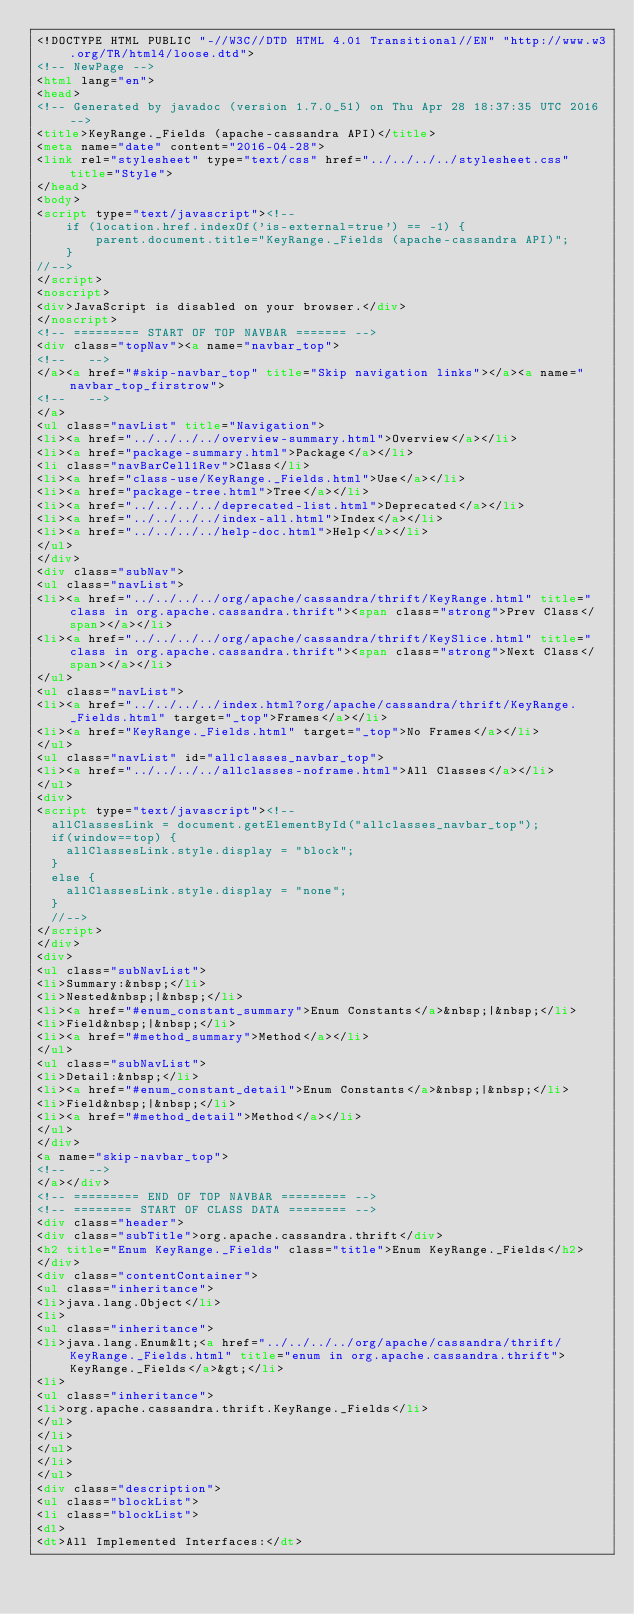Convert code to text. <code><loc_0><loc_0><loc_500><loc_500><_HTML_><!DOCTYPE HTML PUBLIC "-//W3C//DTD HTML 4.01 Transitional//EN" "http://www.w3.org/TR/html4/loose.dtd">
<!-- NewPage -->
<html lang="en">
<head>
<!-- Generated by javadoc (version 1.7.0_51) on Thu Apr 28 18:37:35 UTC 2016 -->
<title>KeyRange._Fields (apache-cassandra API)</title>
<meta name="date" content="2016-04-28">
<link rel="stylesheet" type="text/css" href="../../../../stylesheet.css" title="Style">
</head>
<body>
<script type="text/javascript"><!--
    if (location.href.indexOf('is-external=true') == -1) {
        parent.document.title="KeyRange._Fields (apache-cassandra API)";
    }
//-->
</script>
<noscript>
<div>JavaScript is disabled on your browser.</div>
</noscript>
<!-- ========= START OF TOP NAVBAR ======= -->
<div class="topNav"><a name="navbar_top">
<!--   -->
</a><a href="#skip-navbar_top" title="Skip navigation links"></a><a name="navbar_top_firstrow">
<!--   -->
</a>
<ul class="navList" title="Navigation">
<li><a href="../../../../overview-summary.html">Overview</a></li>
<li><a href="package-summary.html">Package</a></li>
<li class="navBarCell1Rev">Class</li>
<li><a href="class-use/KeyRange._Fields.html">Use</a></li>
<li><a href="package-tree.html">Tree</a></li>
<li><a href="../../../../deprecated-list.html">Deprecated</a></li>
<li><a href="../../../../index-all.html">Index</a></li>
<li><a href="../../../../help-doc.html">Help</a></li>
</ul>
</div>
<div class="subNav">
<ul class="navList">
<li><a href="../../../../org/apache/cassandra/thrift/KeyRange.html" title="class in org.apache.cassandra.thrift"><span class="strong">Prev Class</span></a></li>
<li><a href="../../../../org/apache/cassandra/thrift/KeySlice.html" title="class in org.apache.cassandra.thrift"><span class="strong">Next Class</span></a></li>
</ul>
<ul class="navList">
<li><a href="../../../../index.html?org/apache/cassandra/thrift/KeyRange._Fields.html" target="_top">Frames</a></li>
<li><a href="KeyRange._Fields.html" target="_top">No Frames</a></li>
</ul>
<ul class="navList" id="allclasses_navbar_top">
<li><a href="../../../../allclasses-noframe.html">All Classes</a></li>
</ul>
<div>
<script type="text/javascript"><!--
  allClassesLink = document.getElementById("allclasses_navbar_top");
  if(window==top) {
    allClassesLink.style.display = "block";
  }
  else {
    allClassesLink.style.display = "none";
  }
  //-->
</script>
</div>
<div>
<ul class="subNavList">
<li>Summary:&nbsp;</li>
<li>Nested&nbsp;|&nbsp;</li>
<li><a href="#enum_constant_summary">Enum Constants</a>&nbsp;|&nbsp;</li>
<li>Field&nbsp;|&nbsp;</li>
<li><a href="#method_summary">Method</a></li>
</ul>
<ul class="subNavList">
<li>Detail:&nbsp;</li>
<li><a href="#enum_constant_detail">Enum Constants</a>&nbsp;|&nbsp;</li>
<li>Field&nbsp;|&nbsp;</li>
<li><a href="#method_detail">Method</a></li>
</ul>
</div>
<a name="skip-navbar_top">
<!--   -->
</a></div>
<!-- ========= END OF TOP NAVBAR ========= -->
<!-- ======== START OF CLASS DATA ======== -->
<div class="header">
<div class="subTitle">org.apache.cassandra.thrift</div>
<h2 title="Enum KeyRange._Fields" class="title">Enum KeyRange._Fields</h2>
</div>
<div class="contentContainer">
<ul class="inheritance">
<li>java.lang.Object</li>
<li>
<ul class="inheritance">
<li>java.lang.Enum&lt;<a href="../../../../org/apache/cassandra/thrift/KeyRange._Fields.html" title="enum in org.apache.cassandra.thrift">KeyRange._Fields</a>&gt;</li>
<li>
<ul class="inheritance">
<li>org.apache.cassandra.thrift.KeyRange._Fields</li>
</ul>
</li>
</ul>
</li>
</ul>
<div class="description">
<ul class="blockList">
<li class="blockList">
<dl>
<dt>All Implemented Interfaces:</dt></code> 